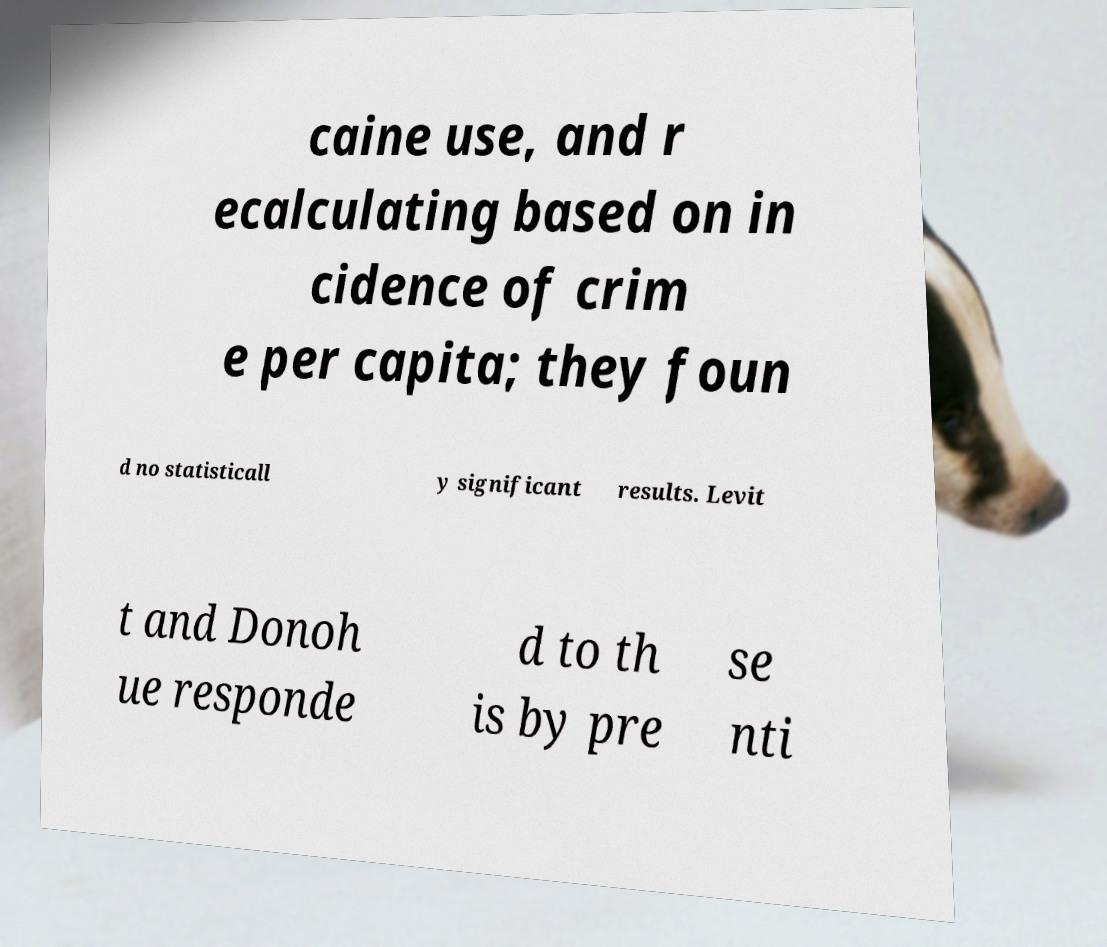Could you extract and type out the text from this image? caine use, and r ecalculating based on in cidence of crim e per capita; they foun d no statisticall y significant results. Levit t and Donoh ue responde d to th is by pre se nti 